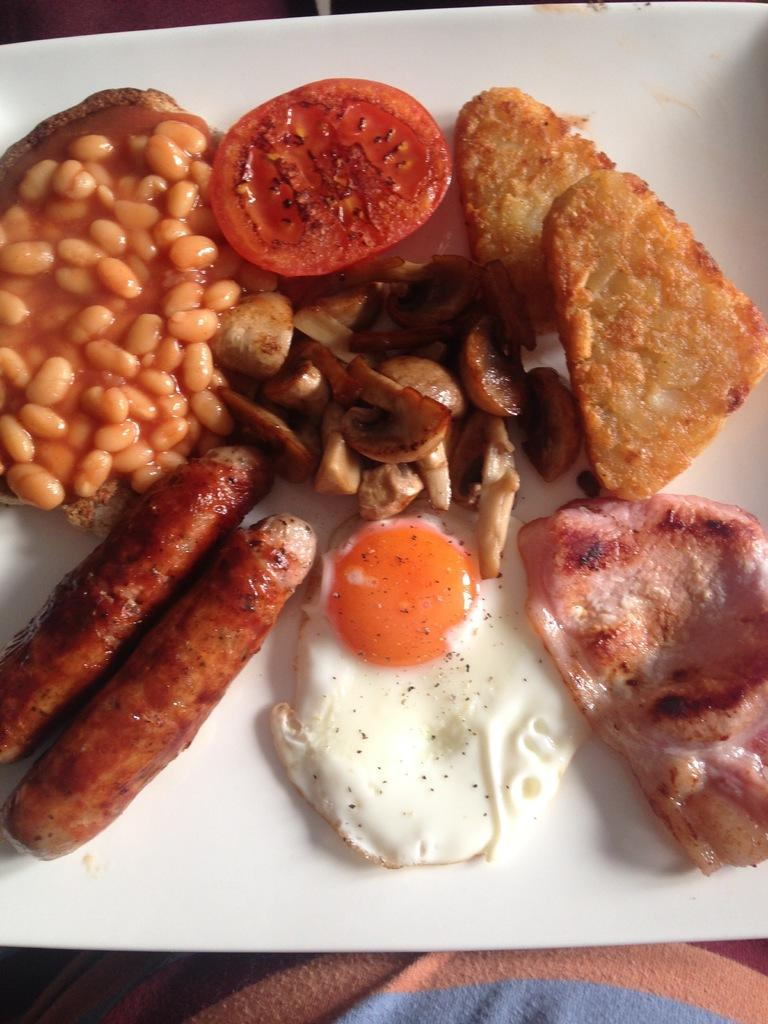What is on the plate in the image? There is food present on the plate in the image. Can you describe the type of food on the plate? The provided facts do not specify the type of food on the plate, so we cannot answer that question definitively. How many times does the person driving the car fall in the image? There is no person driving a car or any mention of falling in the image. 